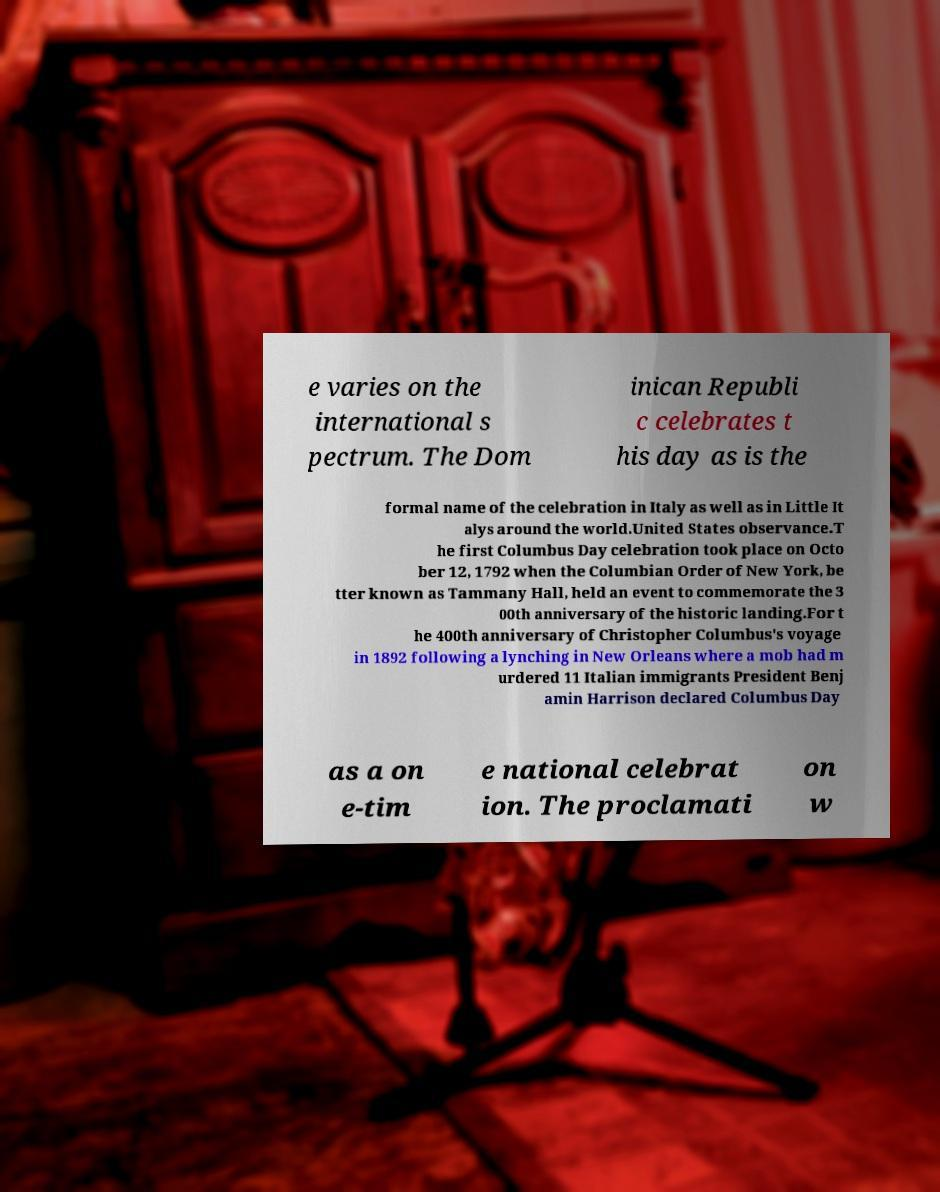Please identify and transcribe the text found in this image. e varies on the international s pectrum. The Dom inican Republi c celebrates t his day as is the formal name of the celebration in Italy as well as in Little It alys around the world.United States observance.T he first Columbus Day celebration took place on Octo ber 12, 1792 when the Columbian Order of New York, be tter known as Tammany Hall, held an event to commemorate the 3 00th anniversary of the historic landing.For t he 400th anniversary of Christopher Columbus's voyage in 1892 following a lynching in New Orleans where a mob had m urdered 11 Italian immigrants President Benj amin Harrison declared Columbus Day as a on e-tim e national celebrat ion. The proclamati on w 